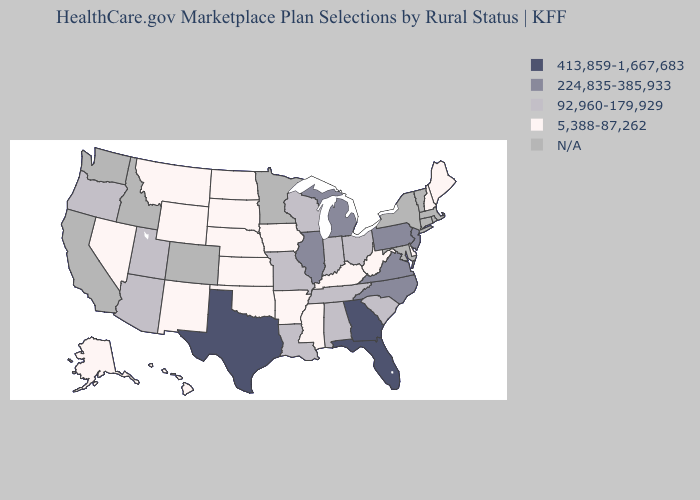Which states hav the highest value in the South?
Short answer required. Florida, Georgia, Texas. Does Georgia have the highest value in the USA?
Concise answer only. Yes. What is the value of West Virginia?
Concise answer only. 5,388-87,262. Name the states that have a value in the range 224,835-385,933?
Answer briefly. Illinois, Michigan, New Jersey, North Carolina, Pennsylvania, Virginia. Which states have the lowest value in the USA?
Concise answer only. Alaska, Arkansas, Delaware, Hawaii, Iowa, Kansas, Kentucky, Maine, Mississippi, Montana, Nebraska, Nevada, New Hampshire, New Mexico, North Dakota, Oklahoma, South Dakota, West Virginia, Wyoming. Name the states that have a value in the range 413,859-1,667,683?
Quick response, please. Florida, Georgia, Texas. Does the first symbol in the legend represent the smallest category?
Write a very short answer. No. What is the value of Missouri?
Answer briefly. 92,960-179,929. What is the value of Montana?
Answer briefly. 5,388-87,262. What is the lowest value in the South?
Give a very brief answer. 5,388-87,262. What is the value of Utah?
Quick response, please. 92,960-179,929. Does Pennsylvania have the highest value in the Northeast?
Answer briefly. Yes. What is the lowest value in the MidWest?
Short answer required. 5,388-87,262. Which states have the lowest value in the South?
Quick response, please. Arkansas, Delaware, Kentucky, Mississippi, Oklahoma, West Virginia. 